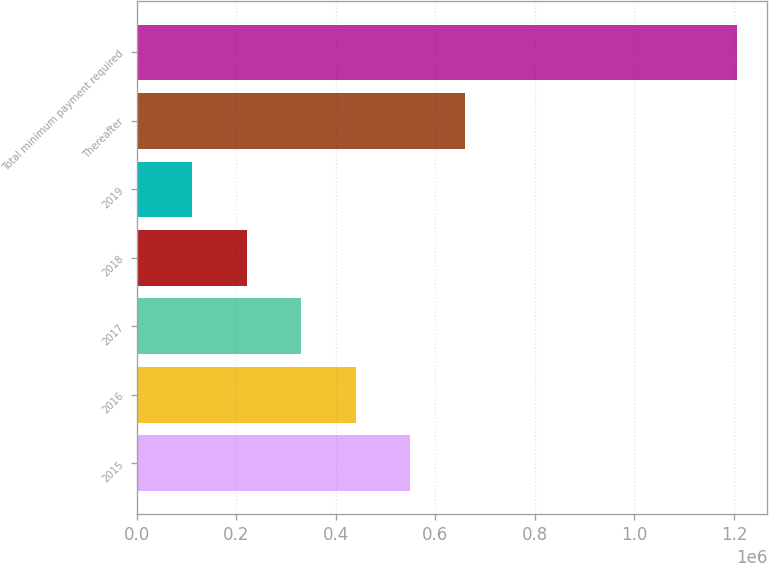Convert chart. <chart><loc_0><loc_0><loc_500><loc_500><bar_chart><fcel>2015<fcel>2016<fcel>2017<fcel>2018<fcel>2019<fcel>Thereafter<fcel>Total minimum payment required<nl><fcel>549322<fcel>439695<fcel>330068<fcel>220440<fcel>110813<fcel>658950<fcel>1.20709e+06<nl></chart> 